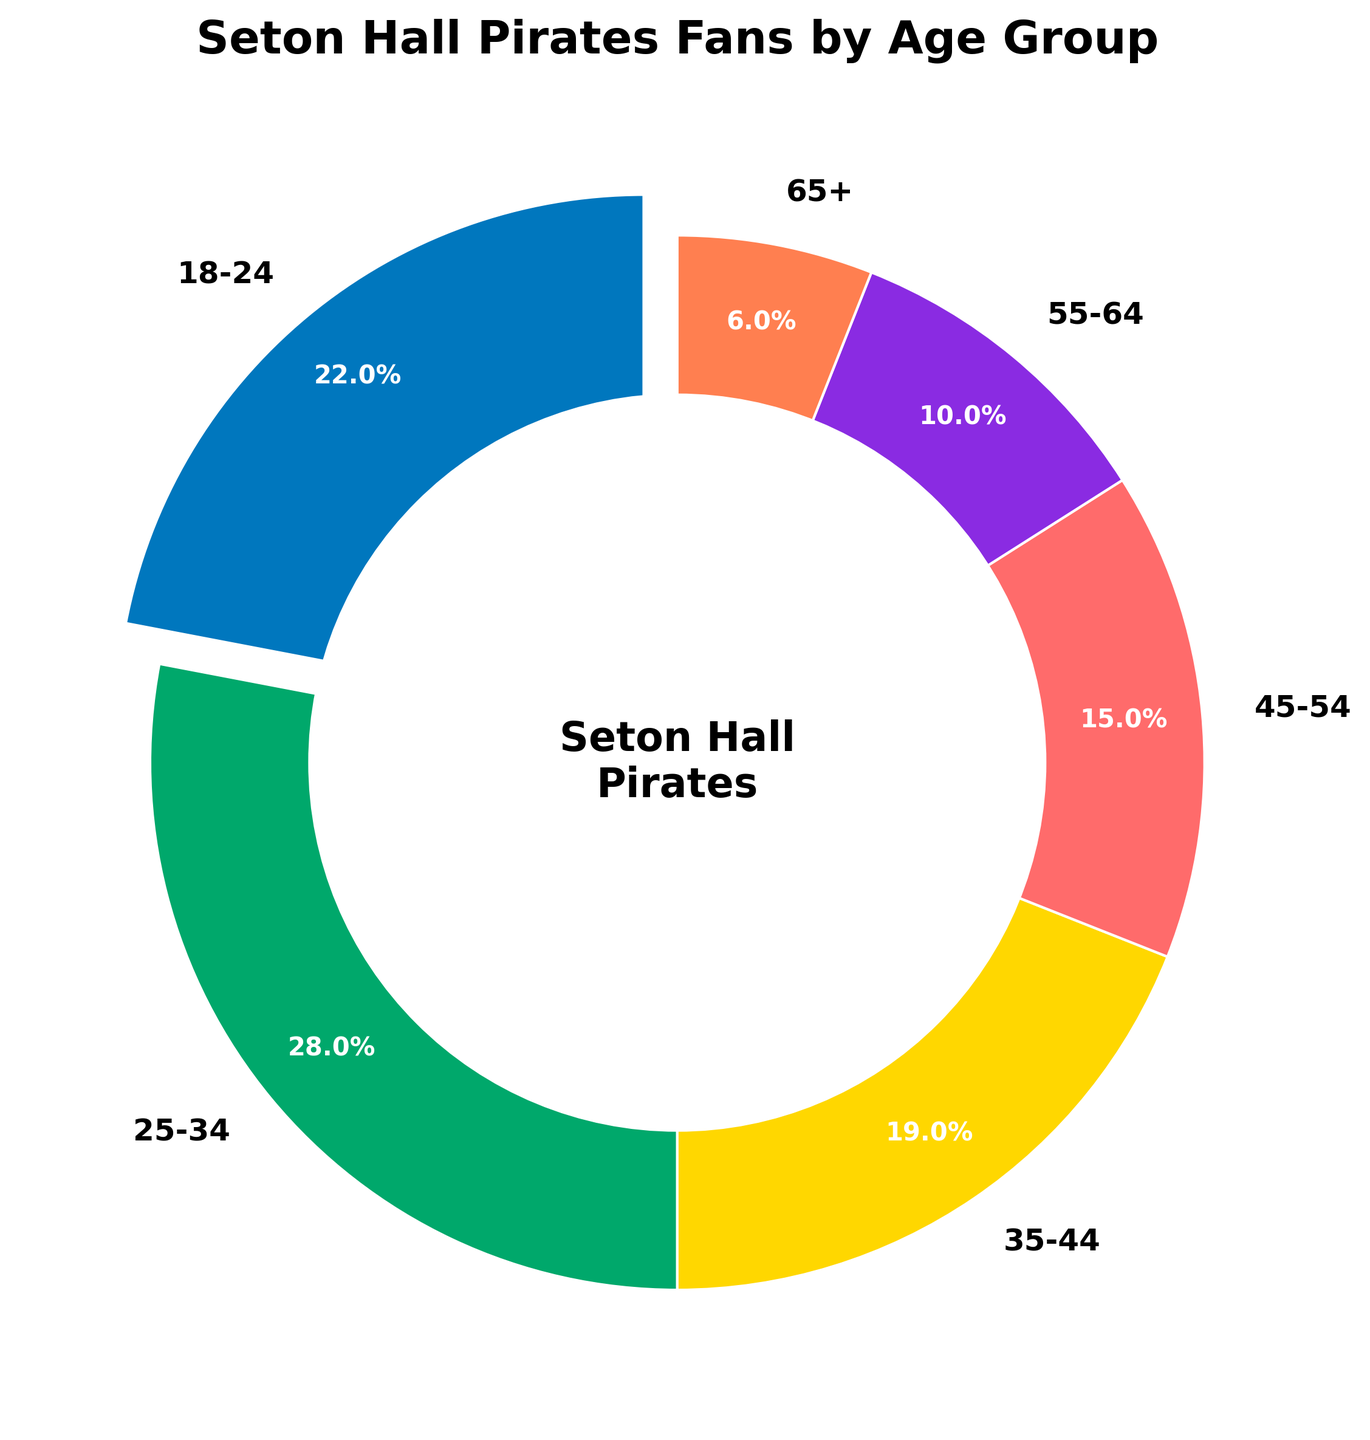Which age group has the highest percentage of Seton Hall Pirates fans? The pie chart shows the breakdown of percentages for different age groups, and the 25-34 age group has the largest slice.
Answer: 25-34 What is the combined percentage of Seton Hall Pirates fans aged between 18-34? Add the percentages of the 18-24 and 25-34 age groups: 22% + 28% = 50%.
Answer: 50% How does the percentage of fans aged 45-54 compare to those aged 55-64? The pie chart indicates the percentage of fans aged 45-54 is 15%, while those aged 55-64 is 10%. Since 15% > 10%, there are more fans in the 45-54 age group.
Answer: 15% > 10% Which age group has the smallest percentage of Seton Hall Pirates fans and what is that percentage? The pie chart shows the smallest slice corresponds to the 65+ age group, which has 6%.
Answer: 65+, 6% Is the percentage of Seton Hall Pirates fans aged 35-44 larger or smaller than those aged 18-24 and by how much? The chart shows the 18-24 age group has 22% and the 35-44 age group has 19%. Since 22% - 19% = 3%, fans aged 35-44 are 3% less than those aged 18-24.
Answer: Smaller by 3% What percentage difference is there between the age groups 25-34 and 35-44? Subtract the percentage of the 35-44 group from the 25-34 group: 28% - 19% = 9%.
Answer: 9% What is the total percentage of fans aged 35-64? Add the percentages of the 35-44, 45-54, and 55-64 age groups: 19% + 15% + 10% = 44%.
Answer: 44% What color represents the age group with the second highest percentage of fans? The pie chart slice for the 25-34 age group (highest) is blue, and the next largest (18-24) is green.
Answer: Green 